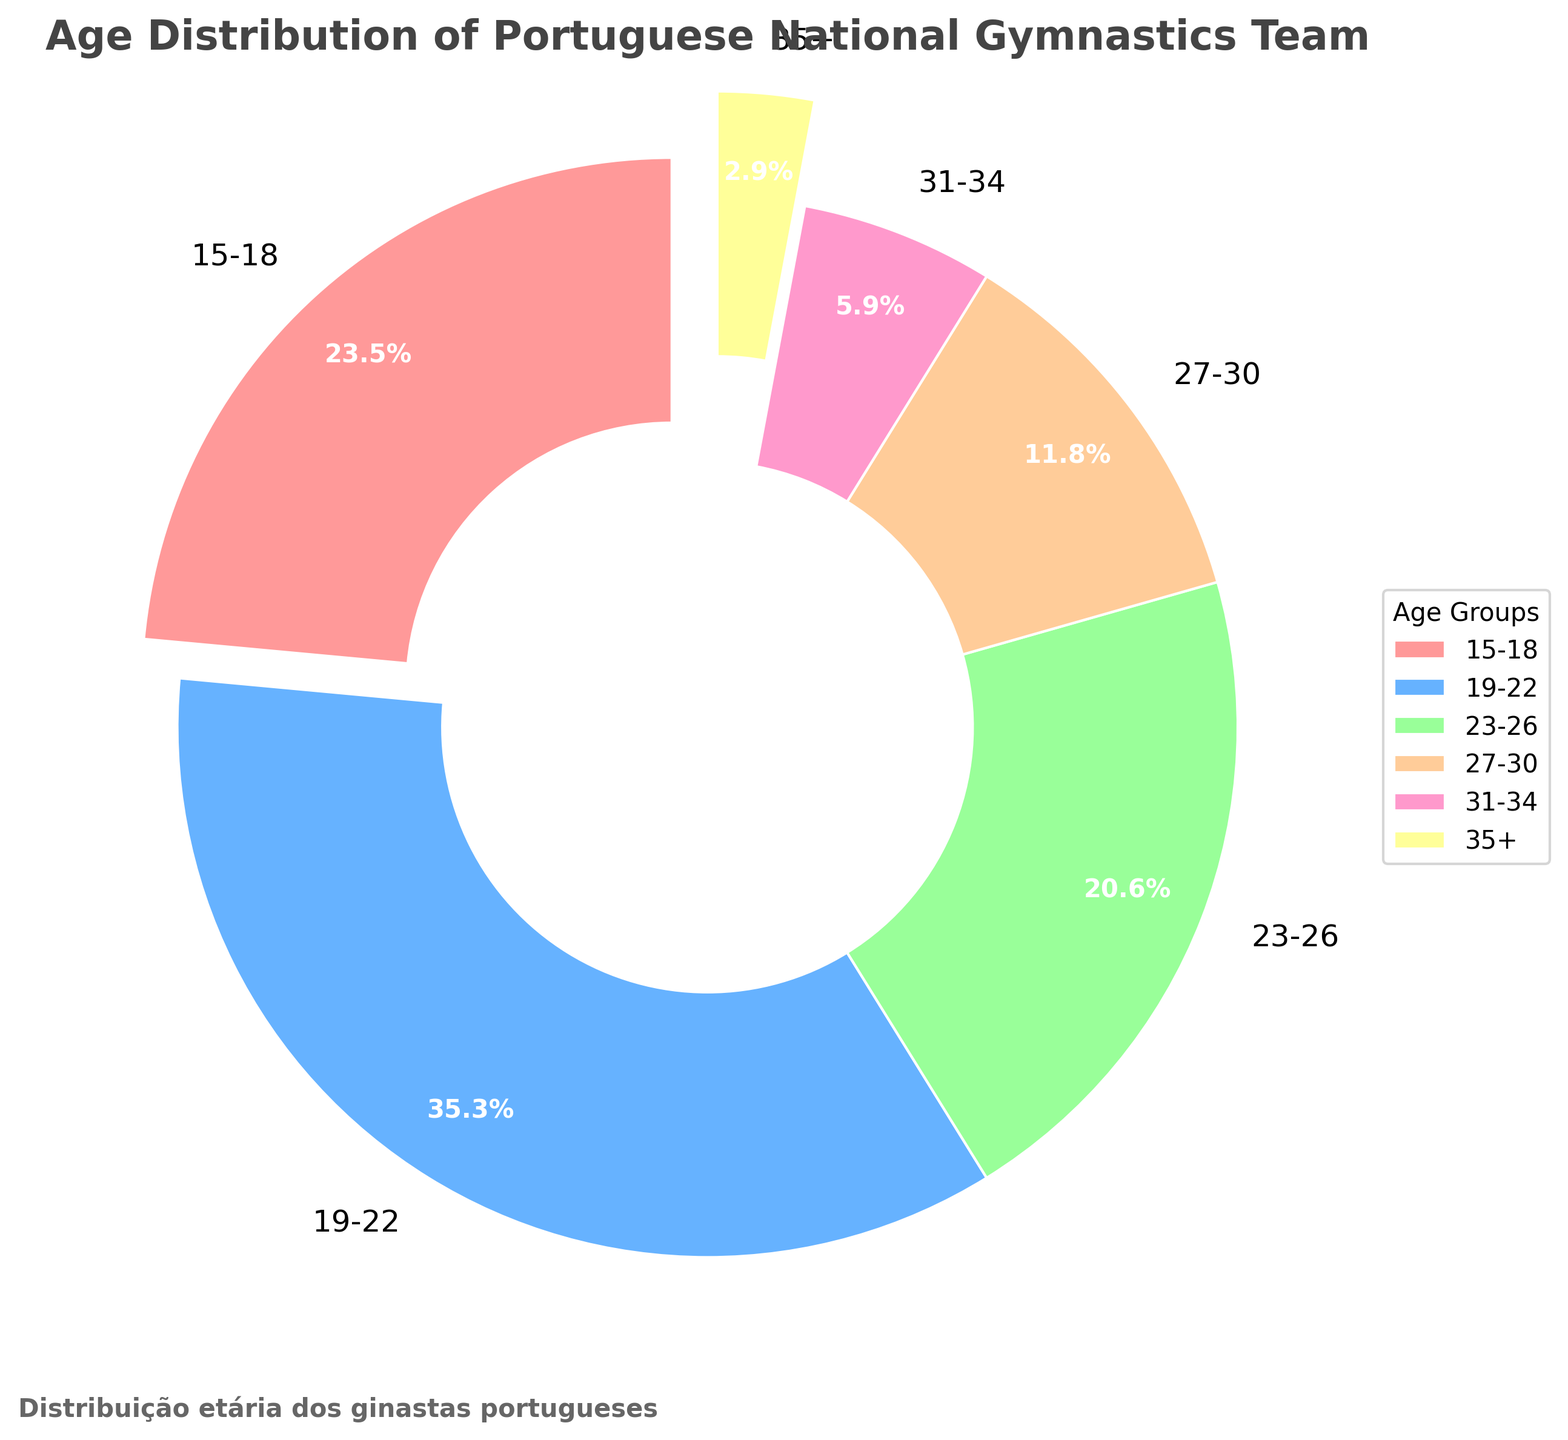Which age group has the highest number of gymnastics team members? By looking at the sizes of the pie chart slices, the age group 19-22 occupies the largest slice, indicating it has the highest number of members.
Answer: 19-22 What percentage of team members are aged between 15 and 22? The figure shows that 15-18 makes up 25.8% and 19-22 makes up 38.7%. Adding these two percentages gives 25.8% + 38.7% = 64.5%.
Answer: 64.5% How many more athletes are in the 19-22 age group compared to the 23-26 age group? The 19-22 age group has 12 athletes, and the 23-26 age group has 7 athletes. Subtracting these gives us 12 - 7 = 5.
Answer: 5 Which age group has the smallest representation in the team? The smallest slice in the pie chart corresponds to the age group 35+, so they have the smallest representation.
Answer: 35+ Compare the number of athletes in the 27-30 age group to those in the 31-34 and 35+ age groups combined. The 27-30 age group has 4 athletes. The 31-34 age group has 2 athletes, and the 35+ group has 1. Adding the latter two gives 2 + 1 = 3, which is less than 4.
Answer: Greater 